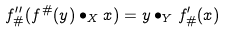<formula> <loc_0><loc_0><loc_500><loc_500>f ^ { \prime \prime } _ { \# } ( f ^ { \# } ( y ) \bullet _ { X } x ) = y \bullet _ { Y } f ^ { \prime } _ { \# } ( x )</formula> 